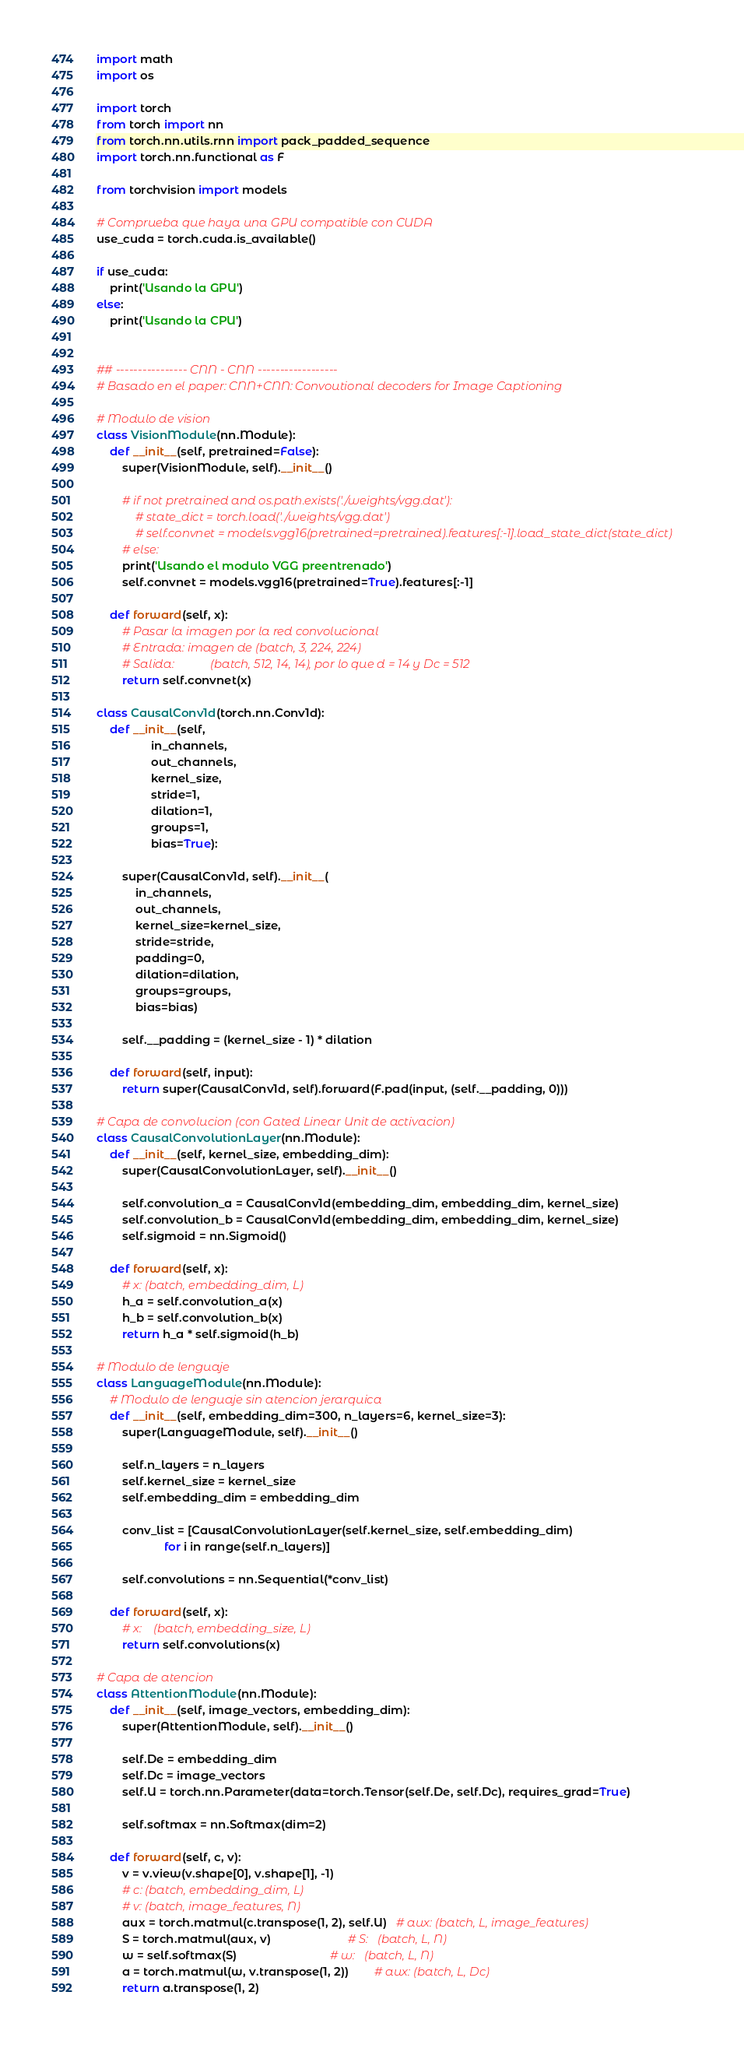<code> <loc_0><loc_0><loc_500><loc_500><_Python_>import math
import os

import torch
from torch import nn
from torch.nn.utils.rnn import pack_padded_sequence
import torch.nn.functional as F

from torchvision import models

# Comprueba que haya una GPU compatible con CUDA
use_cuda = torch.cuda.is_available()

if use_cuda:
    print('Usando la GPU')
else:
    print('Usando la CPU')


## ---------------- CNN - CNN ------------------
# Basado en el paper: CNN+CNN: Convoutional decoders for Image Captioning

# Modulo de vision
class VisionModule(nn.Module):
    def __init__(self, pretrained=False):
        super(VisionModule, self).__init__()

        # if not pretrained and os.path.exists('./weights/vgg.dat'):
            # state_dict = torch.load('./weights/vgg.dat')
            # self.convnet = models.vgg16(pretrained=pretrained).features[:-1].load_state_dict(state_dict)
        # else:
        print('Usando el modulo VGG preentrenado')
        self.convnet = models.vgg16(pretrained=True).features[:-1]

    def forward(self, x):
        # Pasar la imagen por la red convolucional
        # Entrada: imagen de (batch, 3, 224, 224)
        # Salida:            (batch, 512, 14, 14), por lo que d = 14 y Dc = 512
        return self.convnet(x)

class CausalConv1d(torch.nn.Conv1d):
    def __init__(self,
                 in_channels,
                 out_channels,
                 kernel_size,
                 stride=1,
                 dilation=1,
                 groups=1,
                 bias=True):

        super(CausalConv1d, self).__init__(
            in_channels,
            out_channels,
            kernel_size=kernel_size,
            stride=stride,
            padding=0,
            dilation=dilation,
            groups=groups,
            bias=bias)

        self.__padding = (kernel_size - 1) * dilation

    def forward(self, input):
        return super(CausalConv1d, self).forward(F.pad(input, (self.__padding, 0)))

# Capa de convolucion (con Gated Linear Unit de activacion)
class CausalConvolutionLayer(nn.Module):
    def __init__(self, kernel_size, embedding_dim):
        super(CausalConvolutionLayer, self).__init__()

        self.convolution_a = CausalConv1d(embedding_dim, embedding_dim, kernel_size)
        self.convolution_b = CausalConv1d(embedding_dim, embedding_dim, kernel_size)
        self.sigmoid = nn.Sigmoid()

    def forward(self, x):
        # x: (batch, embedding_dim, L)
        h_a = self.convolution_a(x)
        h_b = self.convolution_b(x)
        return h_a * self.sigmoid(h_b)

# Modulo de lenguaje
class LanguageModule(nn.Module):
    # Modulo de lenguaje sin atencion jerarquica
    def __init__(self, embedding_dim=300, n_layers=6, kernel_size=3):
        super(LanguageModule, self).__init__()

        self.n_layers = n_layers
        self.kernel_size = kernel_size
        self.embedding_dim = embedding_dim

        conv_list = [CausalConvolutionLayer(self.kernel_size, self.embedding_dim)
                     for i in range(self.n_layers)]

        self.convolutions = nn.Sequential(*conv_list)

    def forward(self, x):
        # x:    (batch, embedding_size, L)
        return self.convolutions(x)

# Capa de atencion
class AttentionModule(nn.Module):
    def __init__(self, image_vectors, embedding_dim):
        super(AttentionModule, self).__init__()

        self.De = embedding_dim
        self.Dc = image_vectors
        self.U = torch.nn.Parameter(data=torch.Tensor(self.De, self.Dc), requires_grad=True)

        self.softmax = nn.Softmax(dim=2)

    def forward(self, c, v):
        v = v.view(v.shape[0], v.shape[1], -1)
        # c: (batch, embedding_dim, L)
        # v: (batch, image_features, N)
        aux = torch.matmul(c.transpose(1, 2), self.U)   # aux: (batch, L, image_features)
        S = torch.matmul(aux, v)                        # S:   (batch, L, N)
        w = self.softmax(S)                             # w:   (batch, L, N)
        a = torch.matmul(w, v.transpose(1, 2))        # aux: (batch, L, Dc)
        return a.transpose(1, 2)
</code> 